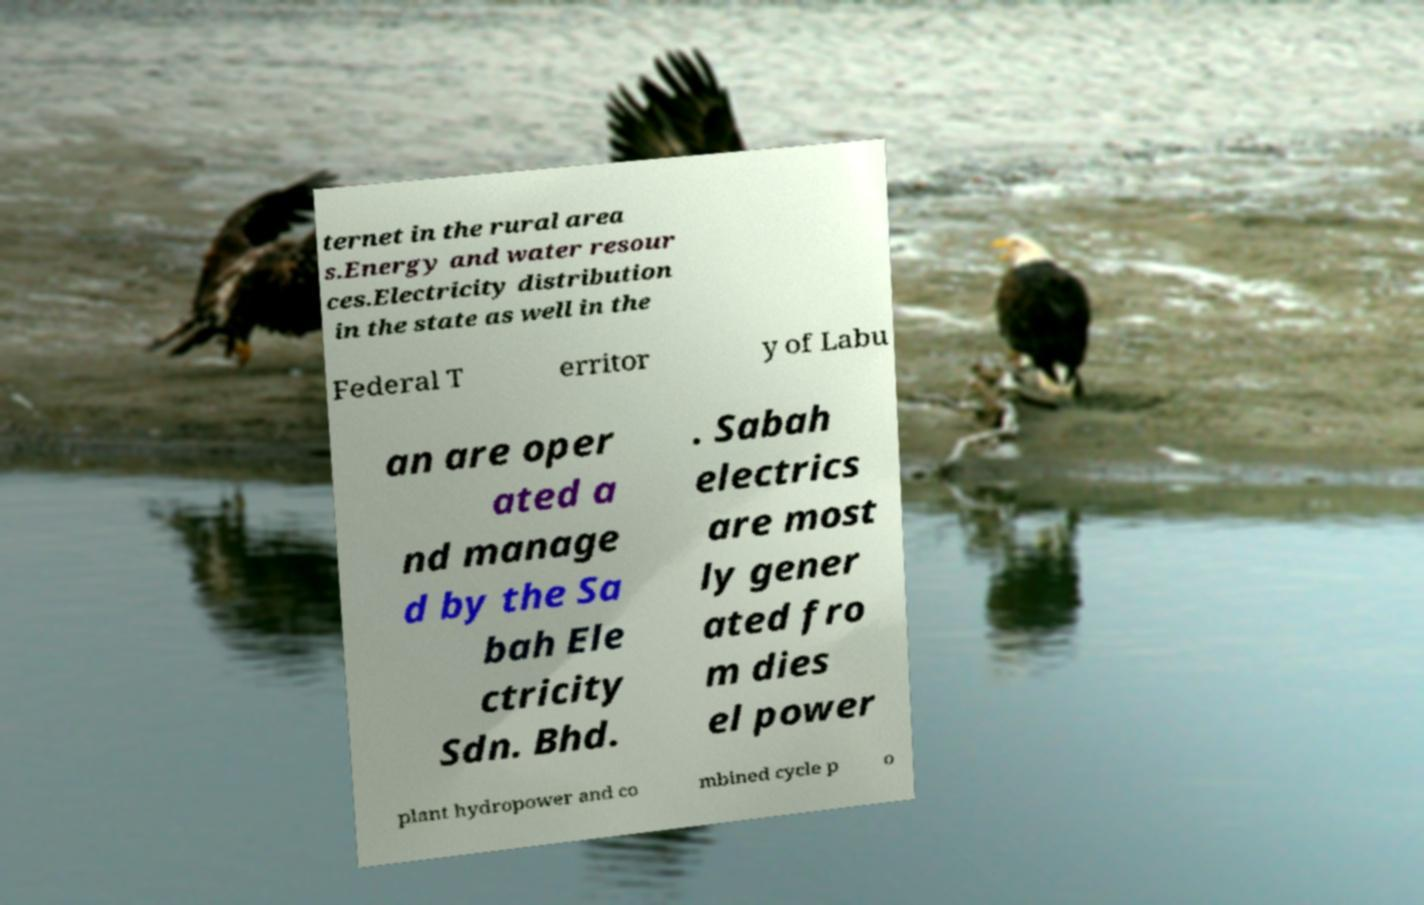I need the written content from this picture converted into text. Can you do that? ternet in the rural area s.Energy and water resour ces.Electricity distribution in the state as well in the Federal T erritor y of Labu an are oper ated a nd manage d by the Sa bah Ele ctricity Sdn. Bhd. . Sabah electrics are most ly gener ated fro m dies el power plant hydropower and co mbined cycle p o 